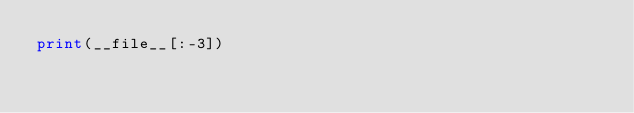Convert code to text. <code><loc_0><loc_0><loc_500><loc_500><_Python_>print(__file__[:-3])
</code> 